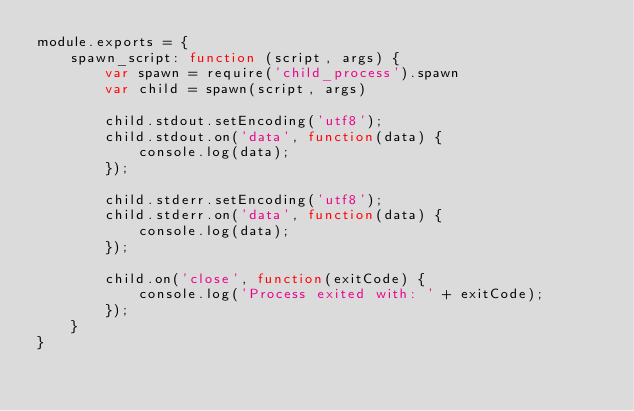<code> <loc_0><loc_0><loc_500><loc_500><_JavaScript_>module.exports = {
    spawn_script: function (script, args) {
        var spawn = require('child_process').spawn
        var child = spawn(script, args)

        child.stdout.setEncoding('utf8');
        child.stdout.on('data', function(data) {
            console.log(data);
        });

        child.stderr.setEncoding('utf8');
        child.stderr.on('data', function(data) {
            console.log(data);
        });

        child.on('close', function(exitCode) {
            console.log('Process exited with: ' + exitCode);
        });
    }
}
</code> 